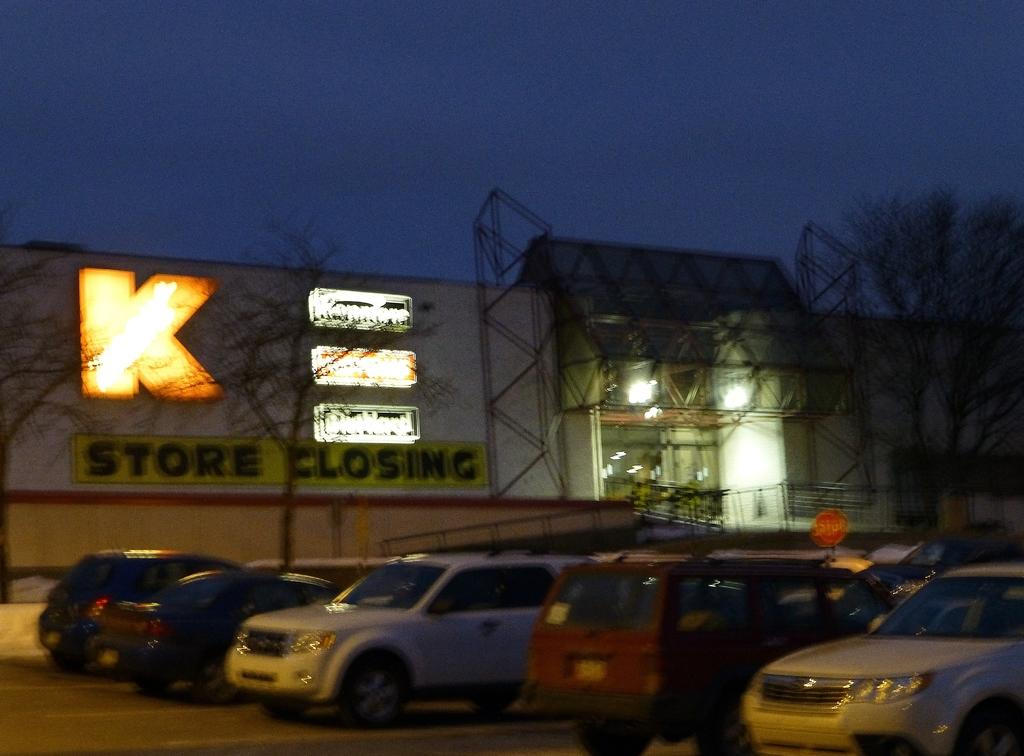<image>
Present a compact description of the photo's key features. Cars are parked in an outdoor lot in front of a store that is going to be closing. 